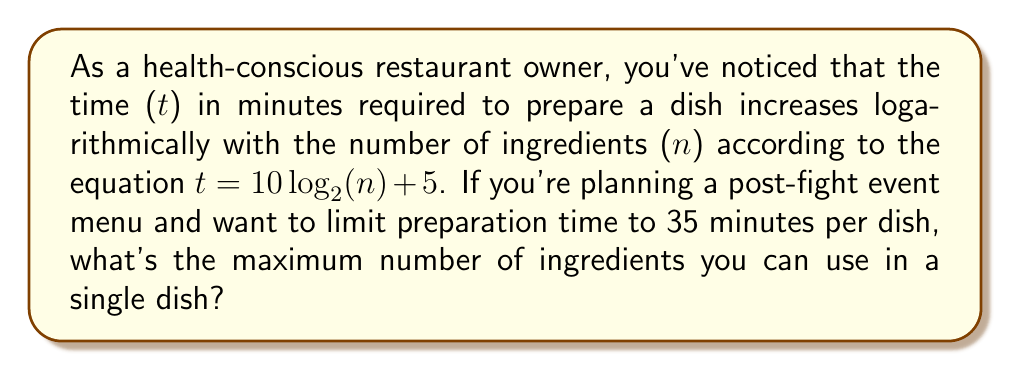Could you help me with this problem? Let's approach this step-by-step:

1) We're given the equation: $t = 10 \log_2(n) + 5$

2) We want to find n when t = 35 minutes. Let's substitute this:

   $35 = 10 \log_2(n) + 5$

3) Subtract 5 from both sides:

   $30 = 10 \log_2(n)$

4) Divide both sides by 10:

   $3 = \log_2(n)$

5) To solve for n, we need to apply the inverse function of $\log_2$, which is $2^x$:

   $2^3 = 2^{\log_2(n)}$

6) Simplify the left side:

   $8 = n$

7) Therefore, the maximum number of ingredients is 8.
Answer: 8 ingredients 